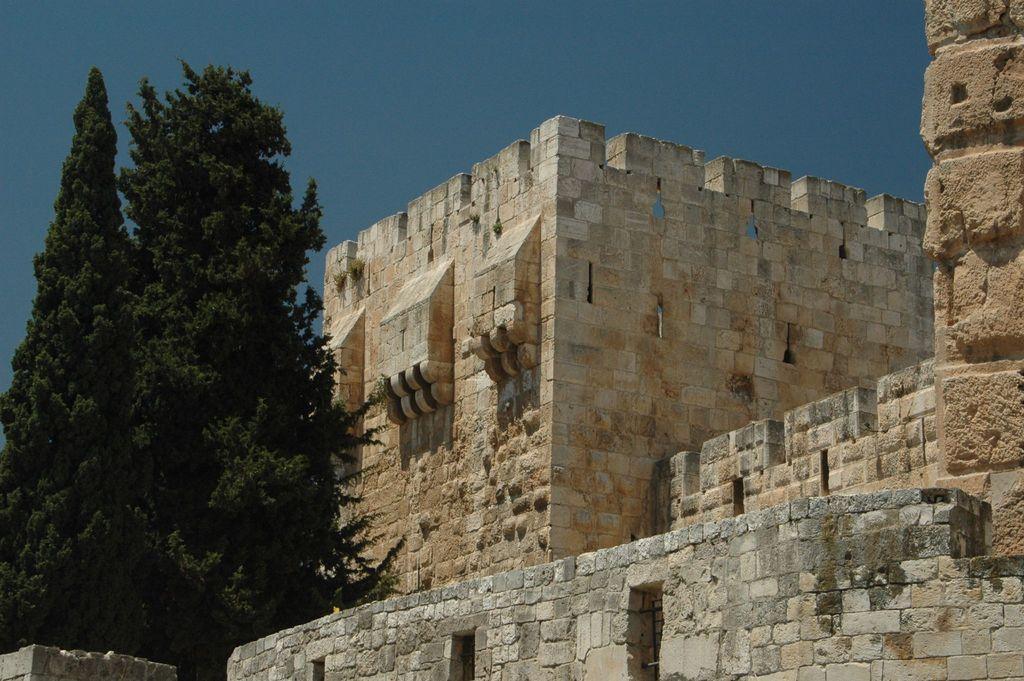Could you give a brief overview of what you see in this image? We can see fort and trees. In the background we can see sky in blue color. 